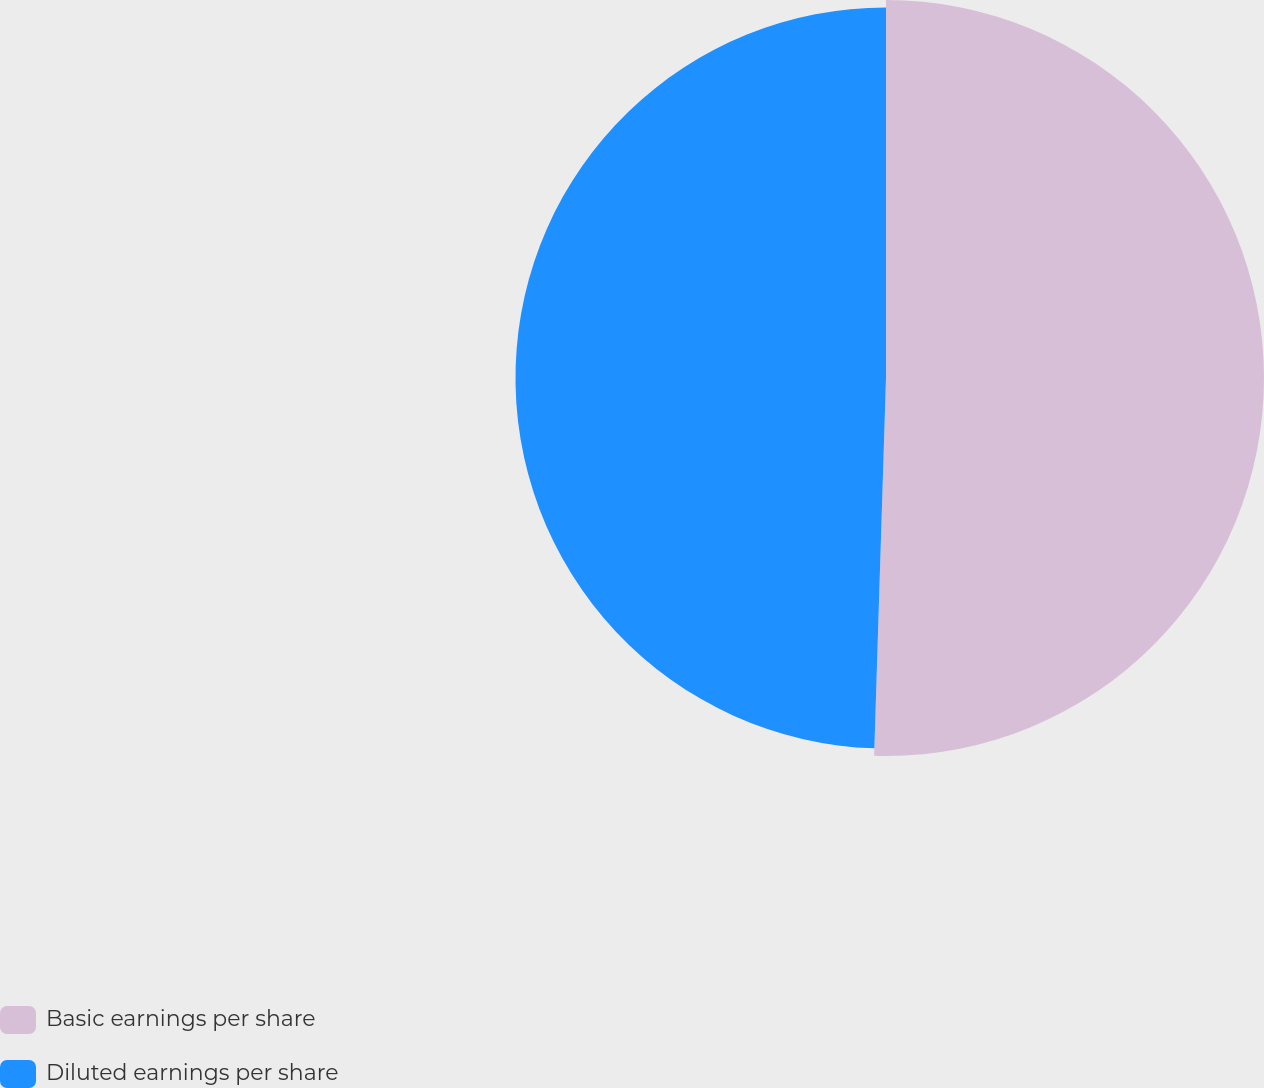<chart> <loc_0><loc_0><loc_500><loc_500><pie_chart><fcel>Basic earnings per share<fcel>Diluted earnings per share<nl><fcel>50.5%<fcel>49.5%<nl></chart> 